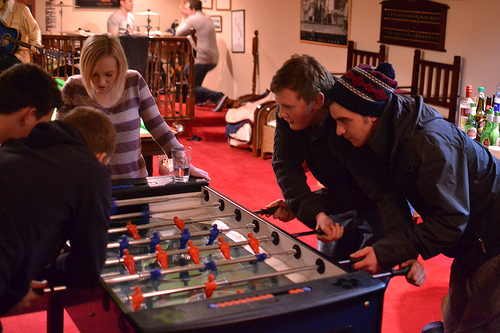<image>
Can you confirm if the hat is on the man? No. The hat is not positioned on the man. They may be near each other, but the hat is not supported by or resting on top of the man. 